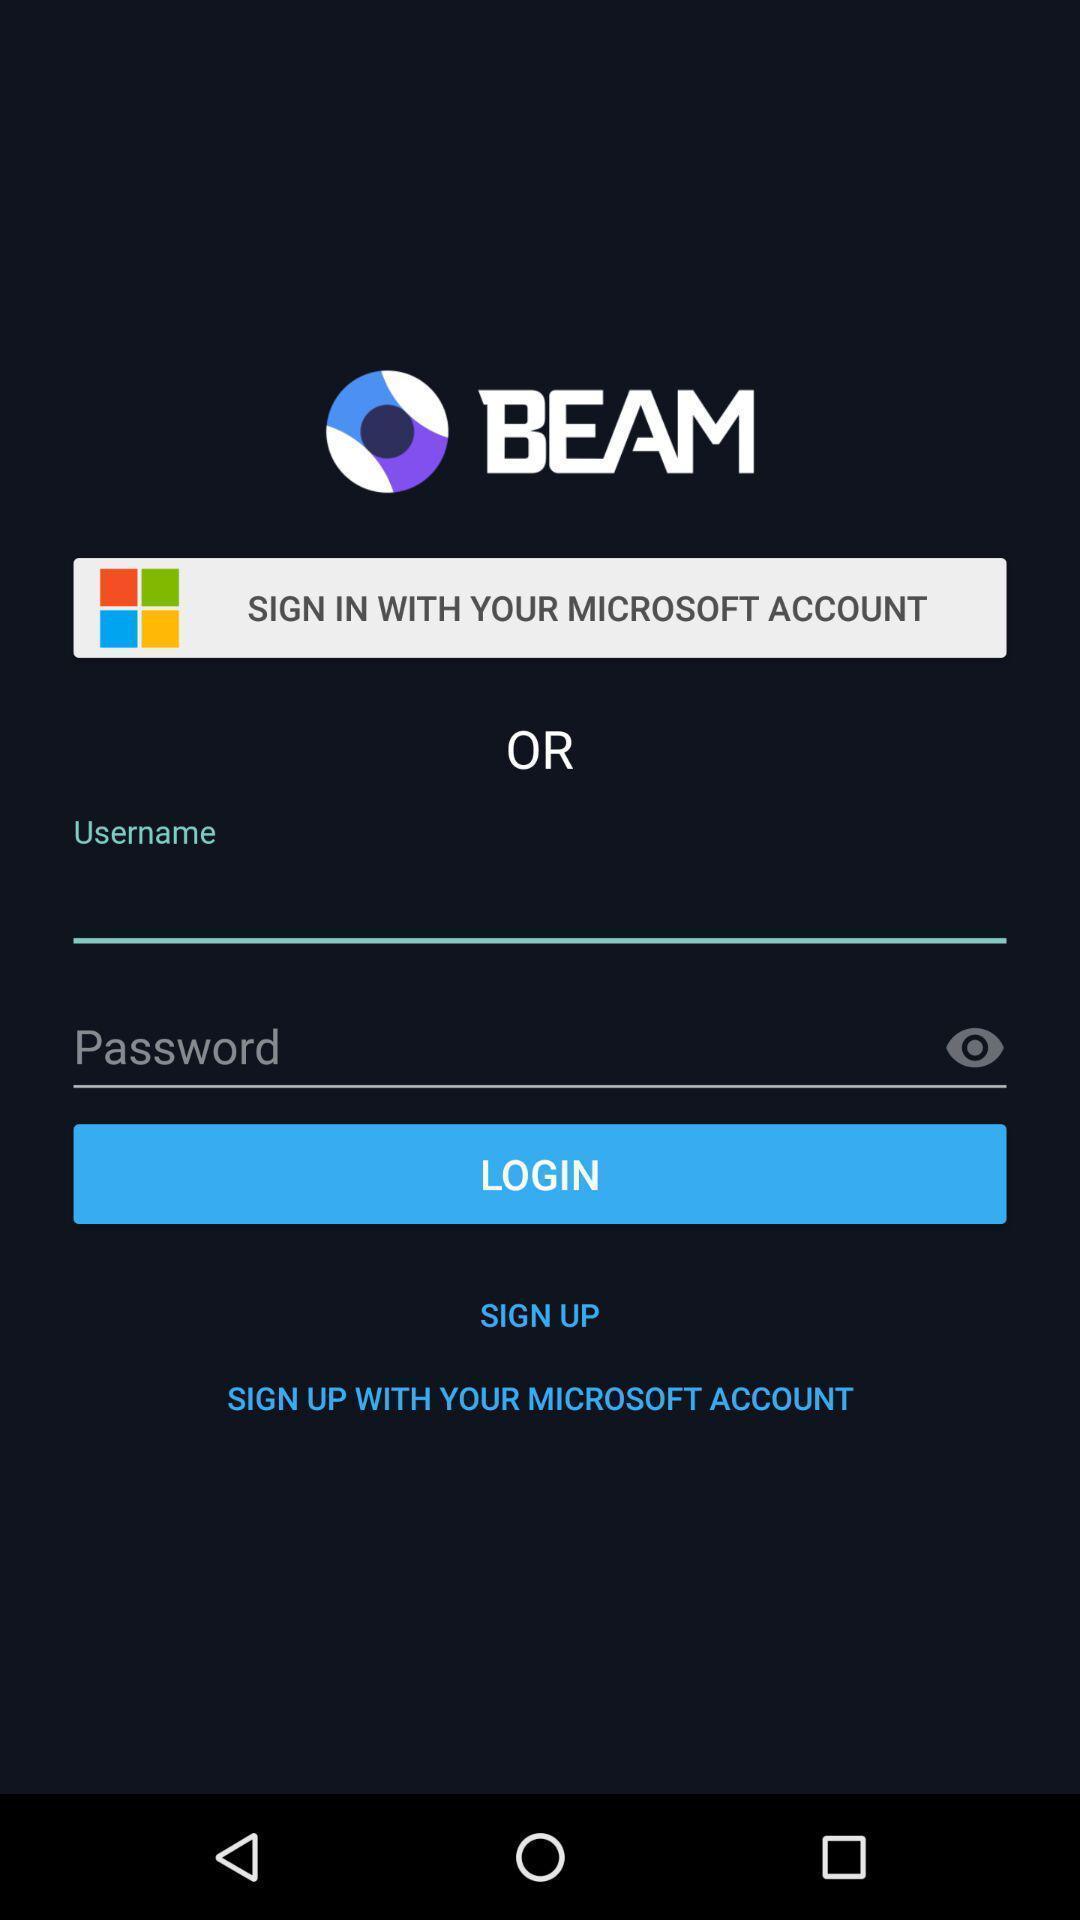Give me a summary of this screen capture. Welcome page asking for login details. 